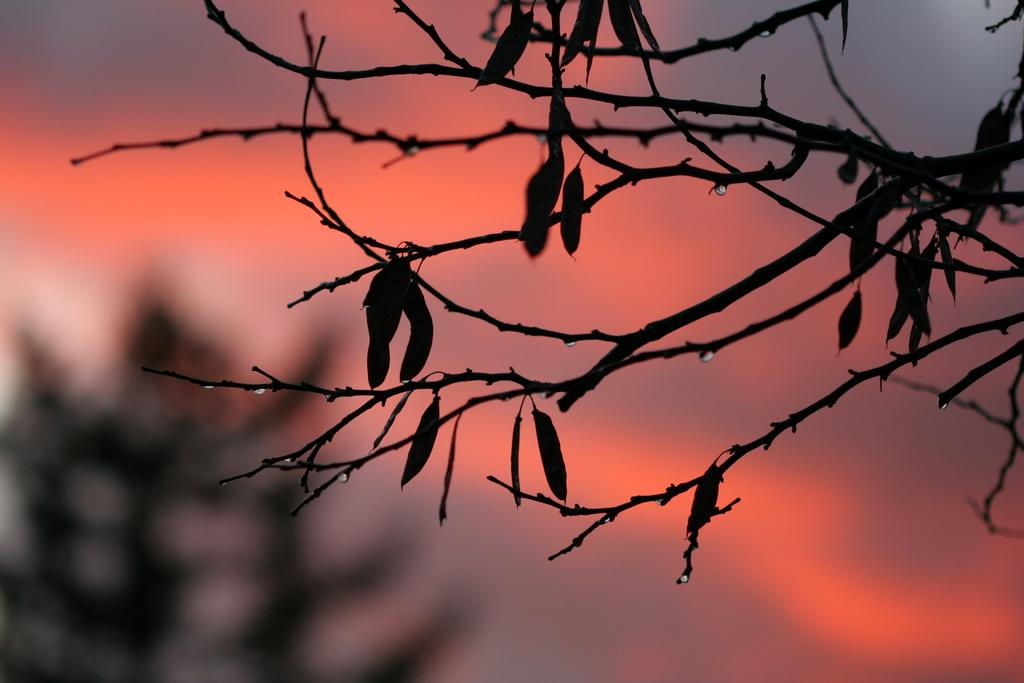What type of vegetation can be seen in the image? There are leaves on the branches of a tree in the image. Can you see a nest in the tree in the image? There is no nest visible in the image; only leaves on the branches of the tree are present. 